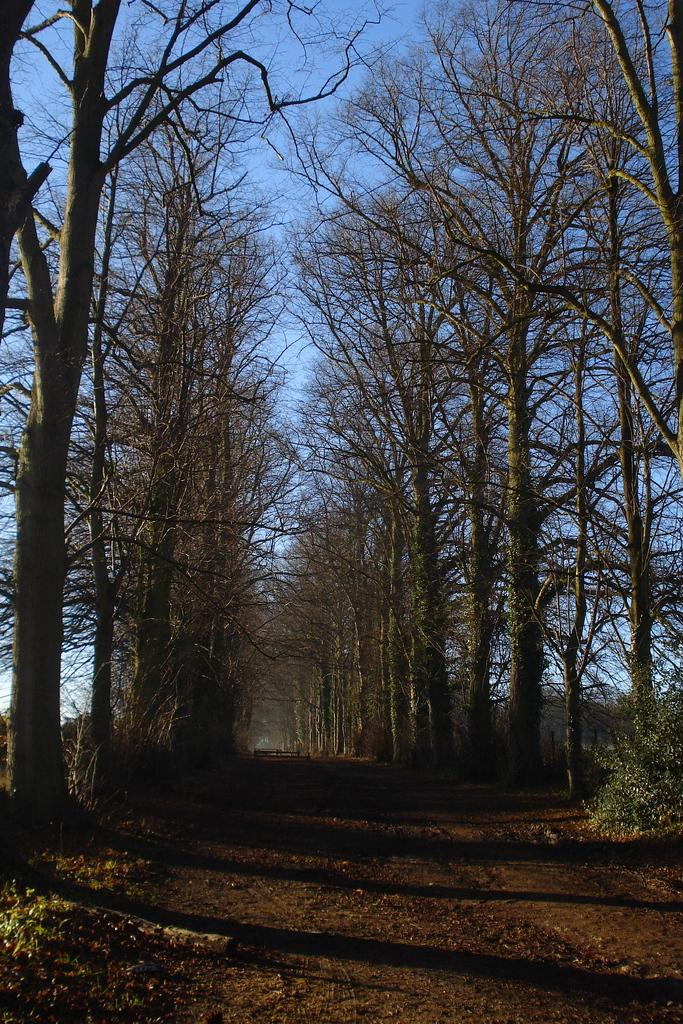What type of terrain is depicted in the image? There is a muddy pathway in the image. What can be seen on either side of the pathway? Dried trees are present on either side of the pathway. Are there any plants visible in the image? Yes, there are plants near the pathway. What is visible in the background of the image? The sky is visible in the background of the image. How does the woman feel about the muddy pathway in the image? There is no woman present in the image, so it is it is not possible to determine her feelings about the muddy pathway. 